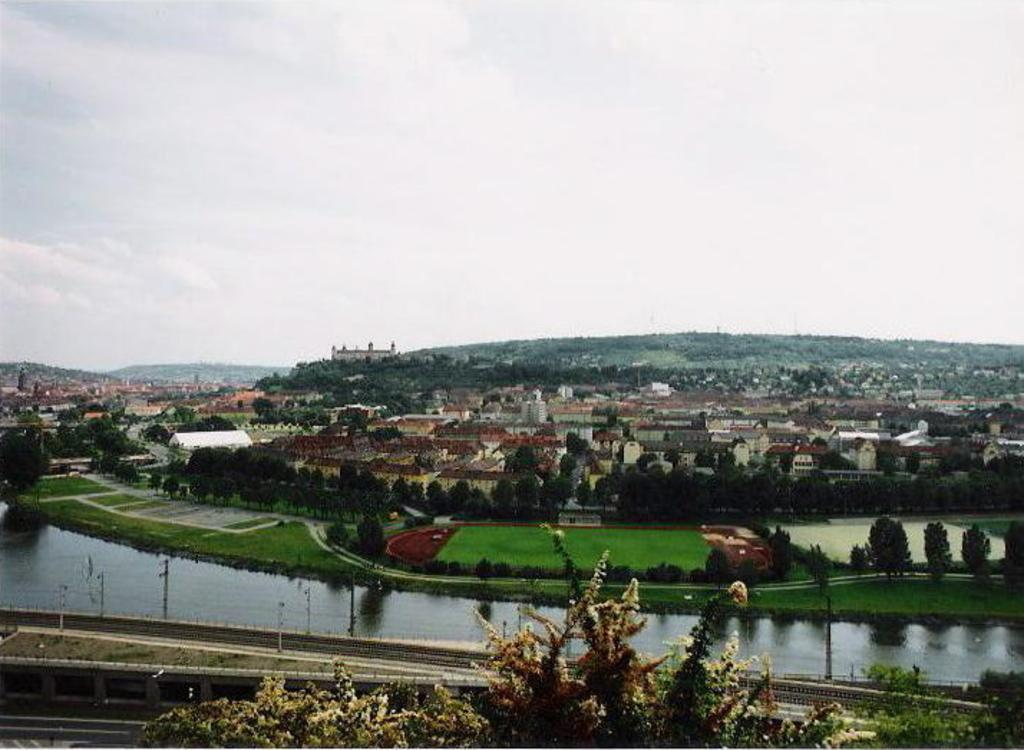What can be seen in the background of the image? In the background of the image, there are hills, thicket, and sky visible. What type of structures are present in the image? There are buildings in the image. What type of vegetation can be seen in the image? There are trees and grass in the image. What natural feature is visible in the image? Water is visible in the image. What man-made structures are present in the image? There are poles and a bridge in the image. How many pizzas are being served on the bridge in the image? There are no pizzas present in the image; it features a bridge over water with other elements such as buildings, trees, and grass. What type of drain is visible in the image? There is no drain visible in the image. 